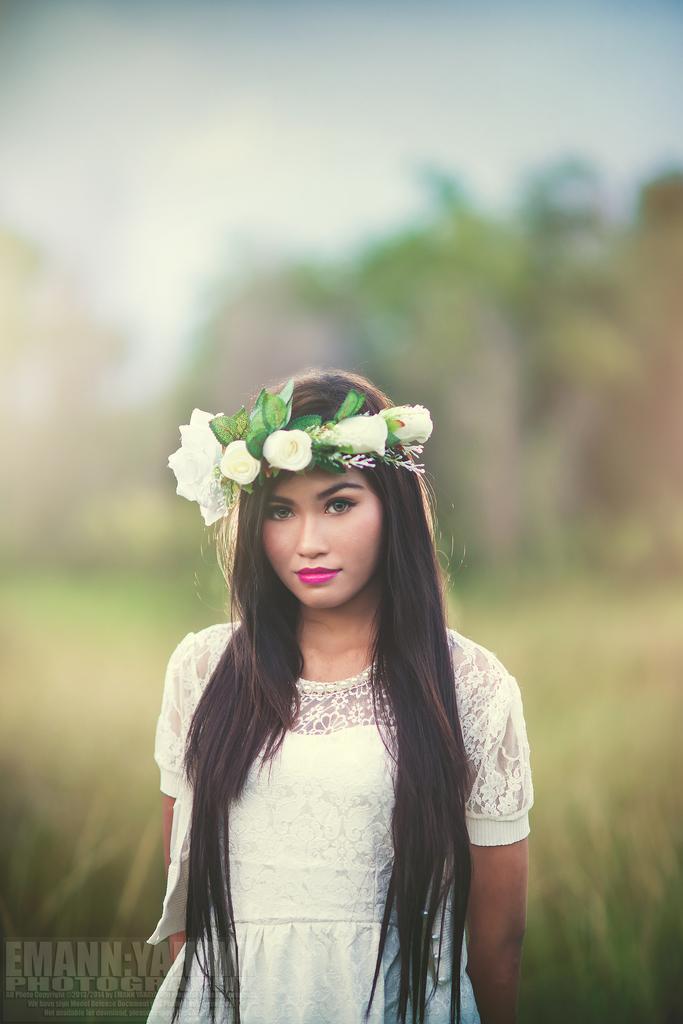Could you give a brief overview of what you see in this image? In this image we can see a woman wearing a tiara and the background is blurred. 